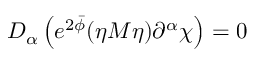<formula> <loc_0><loc_0><loc_500><loc_500>D _ { \alpha } \left ( e ^ { 2 \bar { \phi } } ( \eta M \eta ) \partial ^ { \alpha } \chi \right ) = 0</formula> 